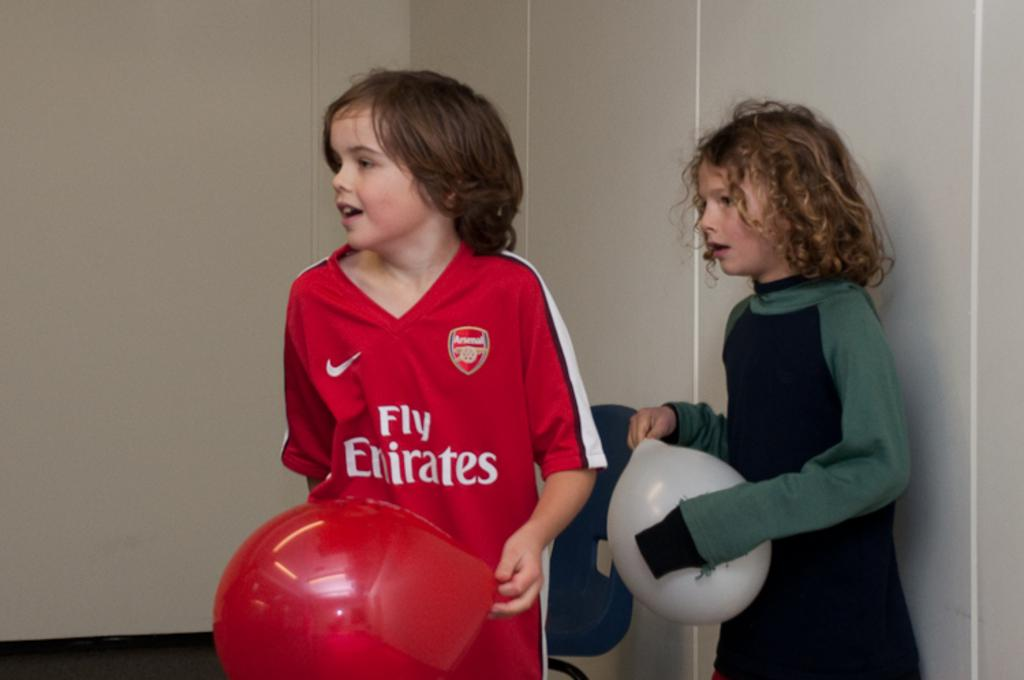<image>
Write a terse but informative summary of the picture. A boy in a Fly Emirates jersey is holding a red balloon. 